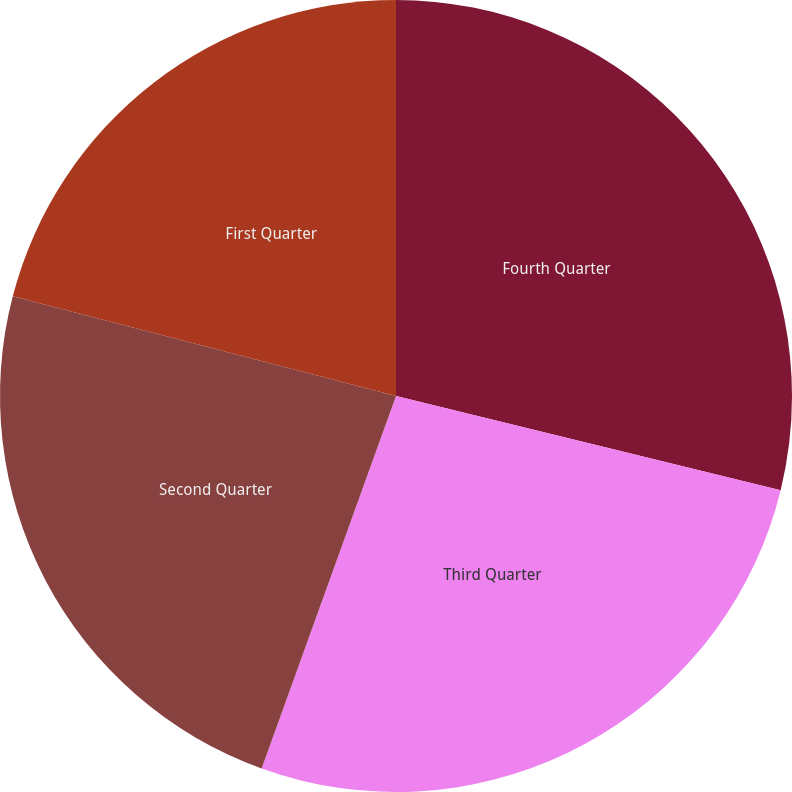Convert chart to OTSL. <chart><loc_0><loc_0><loc_500><loc_500><pie_chart><fcel>Fourth Quarter<fcel>Third Quarter<fcel>Second Quarter<fcel>First Quarter<nl><fcel>28.82%<fcel>26.69%<fcel>23.54%<fcel>20.95%<nl></chart> 